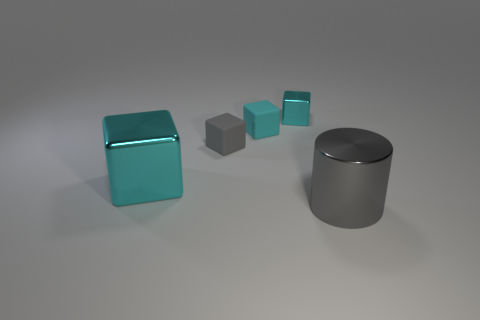Subtract all brown cylinders. How many cyan cubes are left? 3 Subtract all gray cubes. How many cubes are left? 3 Subtract all blue blocks. Subtract all blue cylinders. How many blocks are left? 4 Add 2 cyan spheres. How many objects exist? 7 Subtract all cylinders. How many objects are left? 4 Subtract 0 brown balls. How many objects are left? 5 Subtract all yellow blocks. Subtract all blocks. How many objects are left? 1 Add 4 gray metal cylinders. How many gray metal cylinders are left? 5 Add 1 matte things. How many matte things exist? 3 